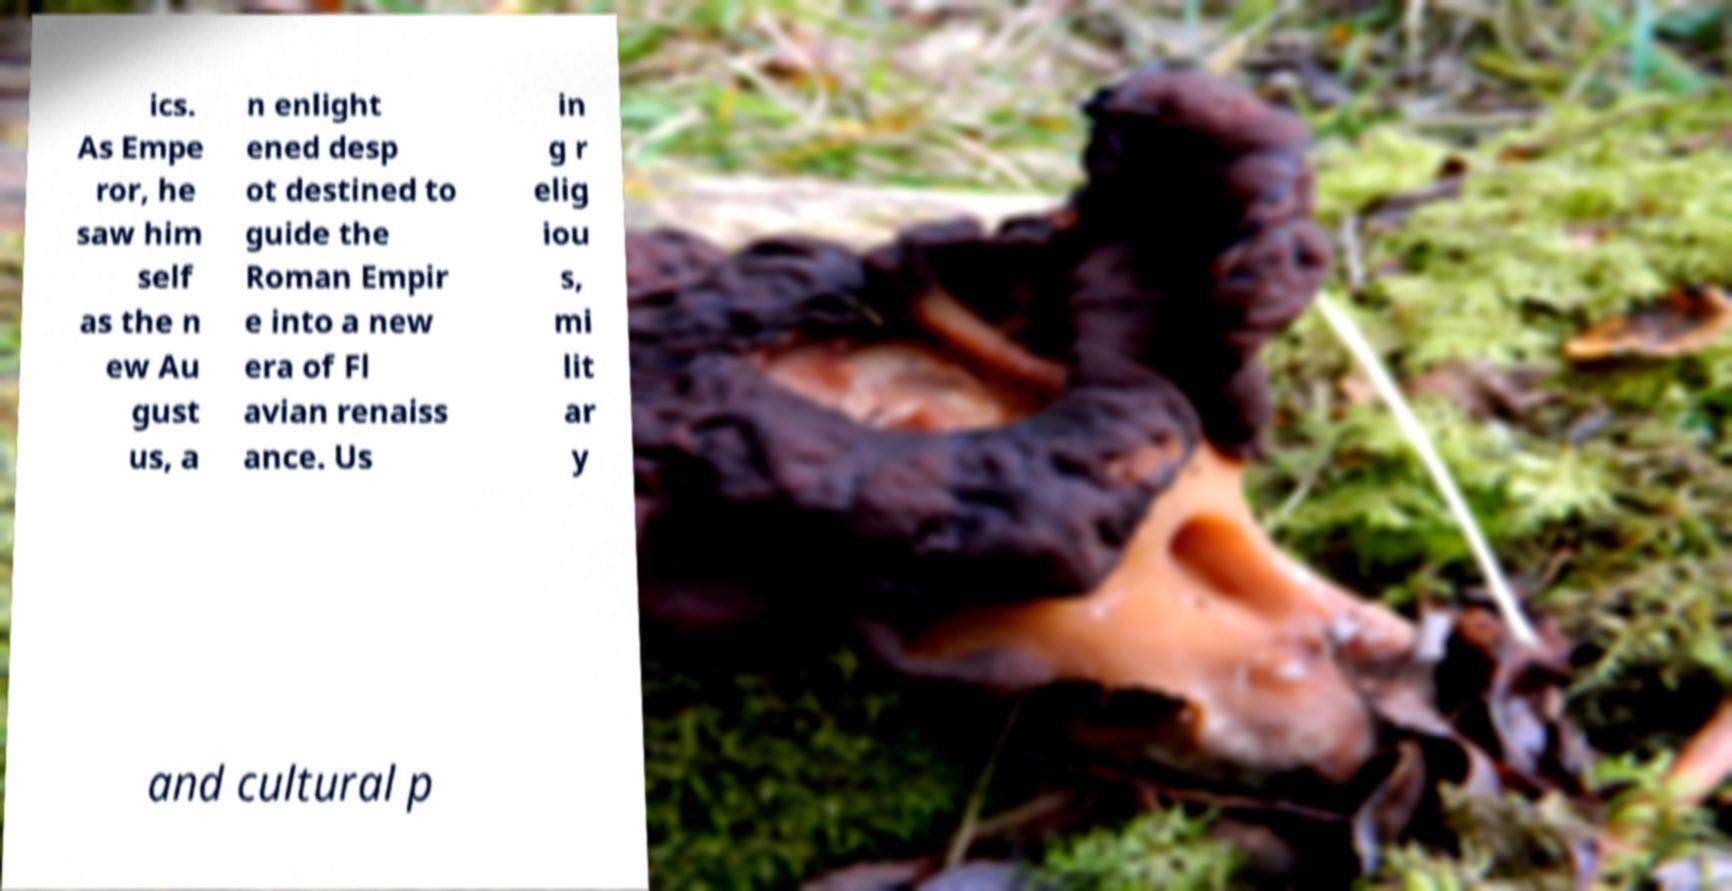Could you assist in decoding the text presented in this image and type it out clearly? ics. As Empe ror, he saw him self as the n ew Au gust us, a n enlight ened desp ot destined to guide the Roman Empir e into a new era of Fl avian renaiss ance. Us in g r elig iou s, mi lit ar y and cultural p 